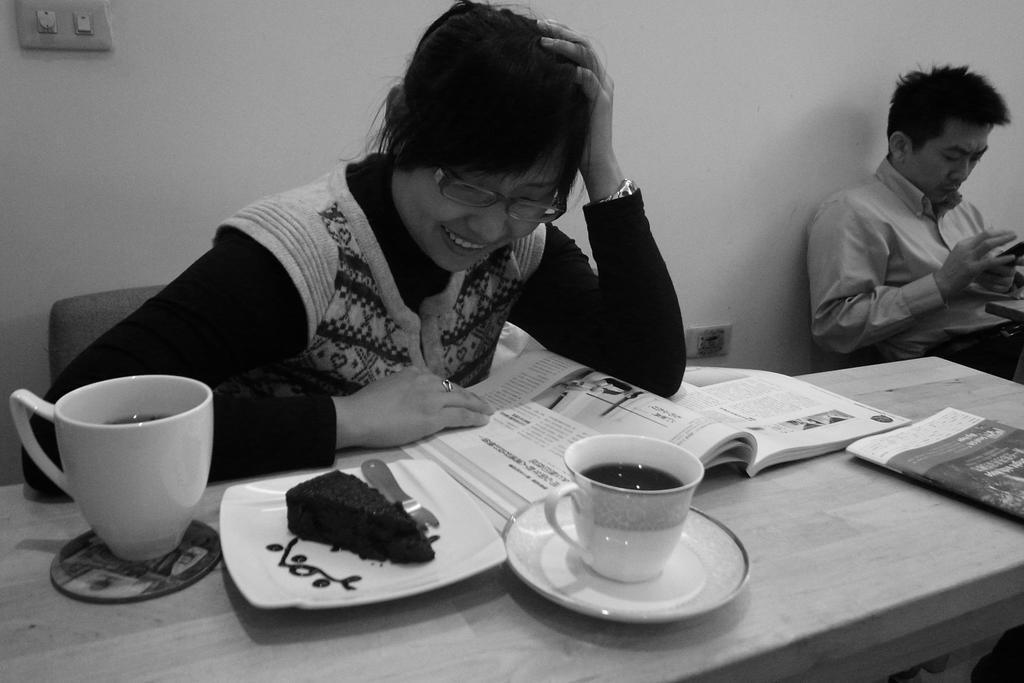Please provide a concise description of this image. In this image we see a woman is sitting on the chair is looking at the book in front of her. There are cups, saucer, plate with cake, fork and books on the table. In the background there is a man sitting. 